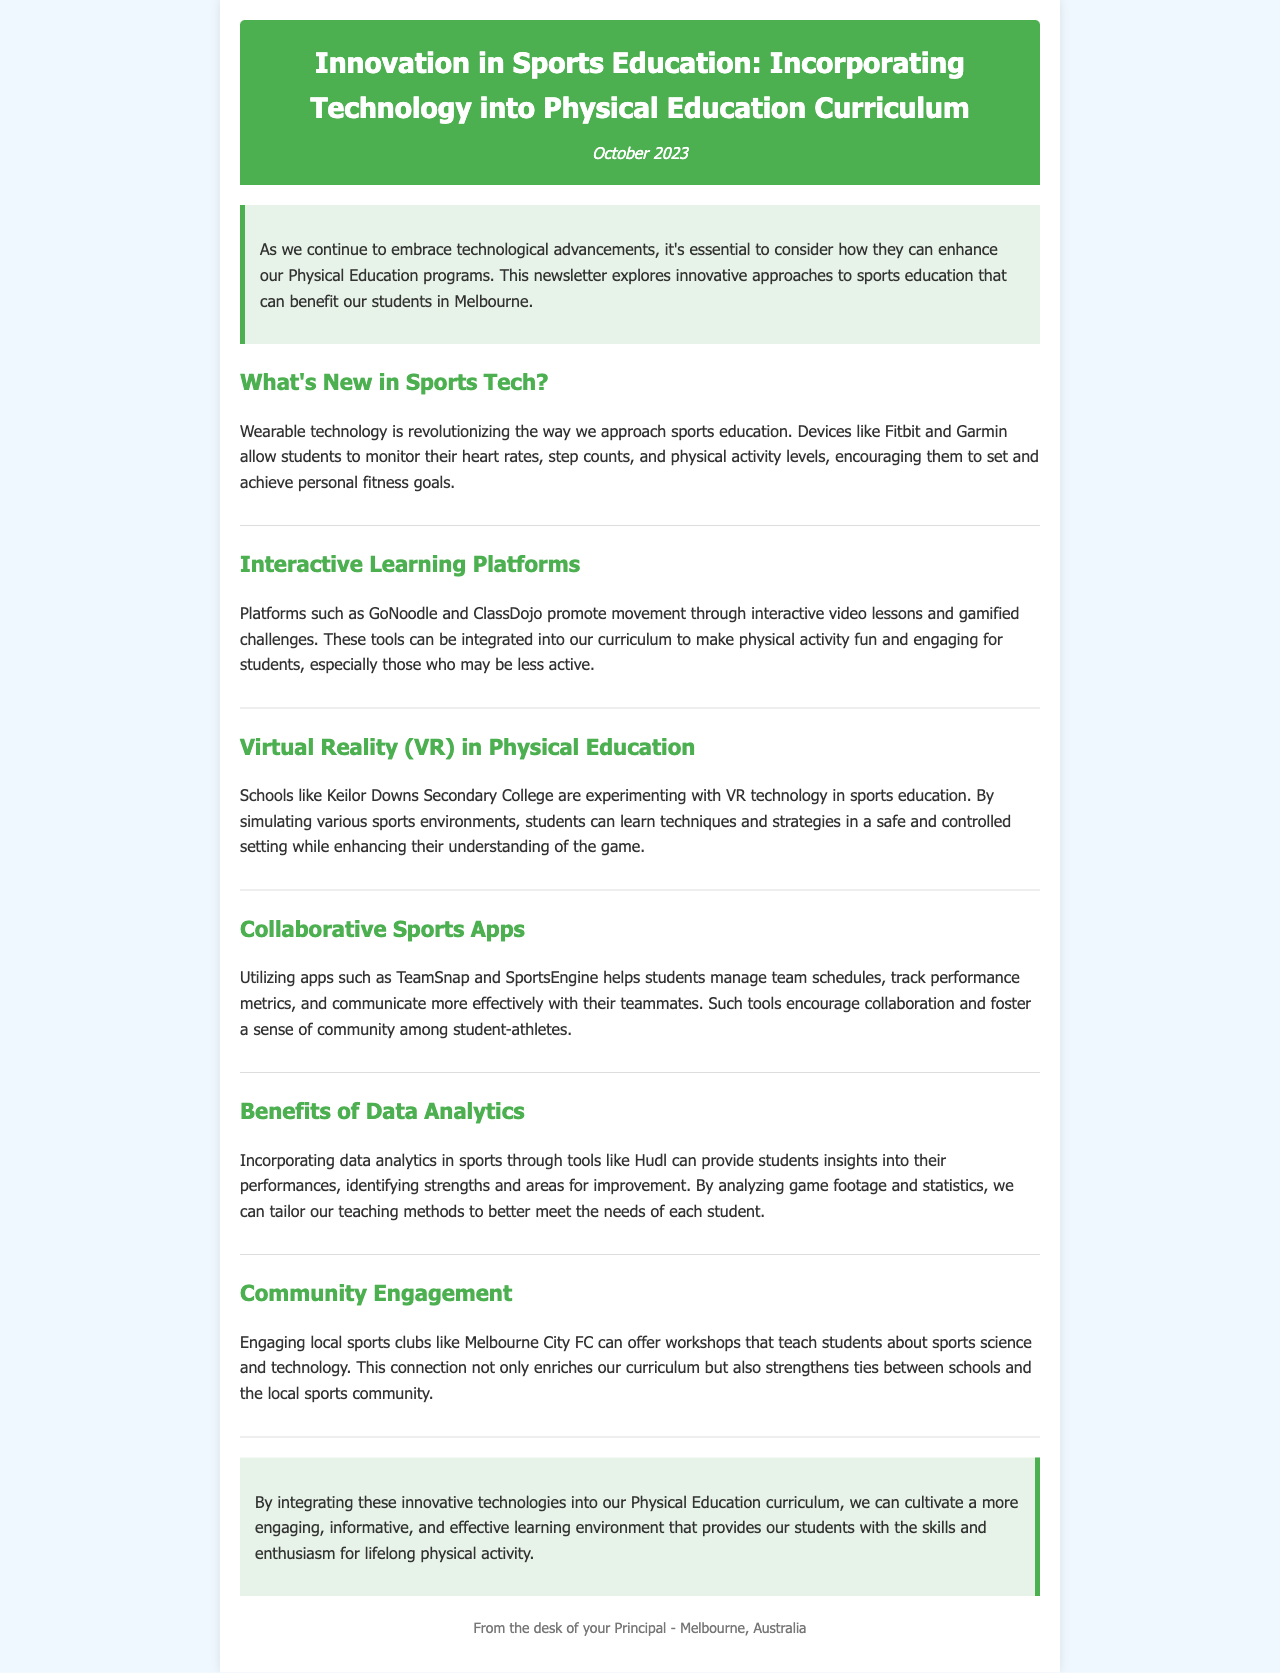What is the title of the newsletter? The title is stated at the top of the document, highlighting the main topic discussed.
Answer: Innovation in Sports Education: Incorporating Technology into Physical Education Curriculum When was the newsletter published? The publication date is mentioned under the title in the header.
Answer: October 2023 What type of technology is mentioned for monitoring physical activity? The document lists specific devices that track fitness metrics used in sports education.
Answer: Fitbit and Garmin Which platform promotes movement through interactive video lessons? The section discussing interactive learning platforms identifies a specific one that encourages physical activity.
Answer: GoNoodle What is one example of a school using VR in sports education? The newsletter provides a specific school that is experimenting with virtual reality technology.
Answer: Keilor Downs Secondary College What is the name of an app that helps manage team schedules? The document lists apps designed to enhance communication and organization among athletes.
Answer: TeamSnap Which local sports club is mentioned for community engagement activities? The newsletter references a local team that can provide workshops related to sports education.
Answer: Melbourne City FC How do data analytics benefit students in sports? The document explains how analytics provide insights into performance and areas for enhancement.
Answer: Identifying strengths and areas for improvement 